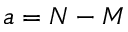<formula> <loc_0><loc_0><loc_500><loc_500>a = N - M</formula> 